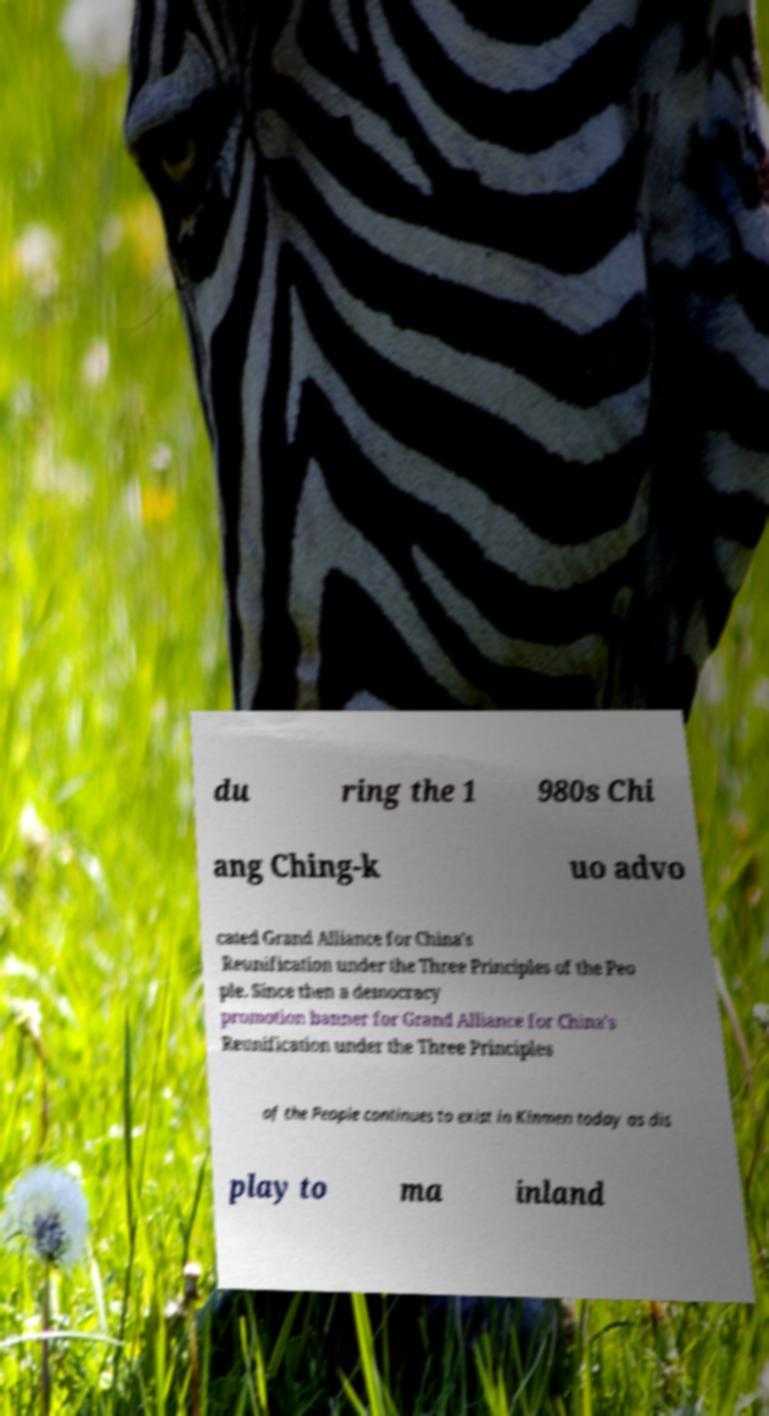Could you extract and type out the text from this image? du ring the 1 980s Chi ang Ching-k uo advo cated Grand Alliance for China's Reunification under the Three Principles of the Peo ple. Since then a democracy promotion banner for Grand Alliance for China's Reunification under the Three Principles of the People continues to exist in Kinmen today as dis play to ma inland 